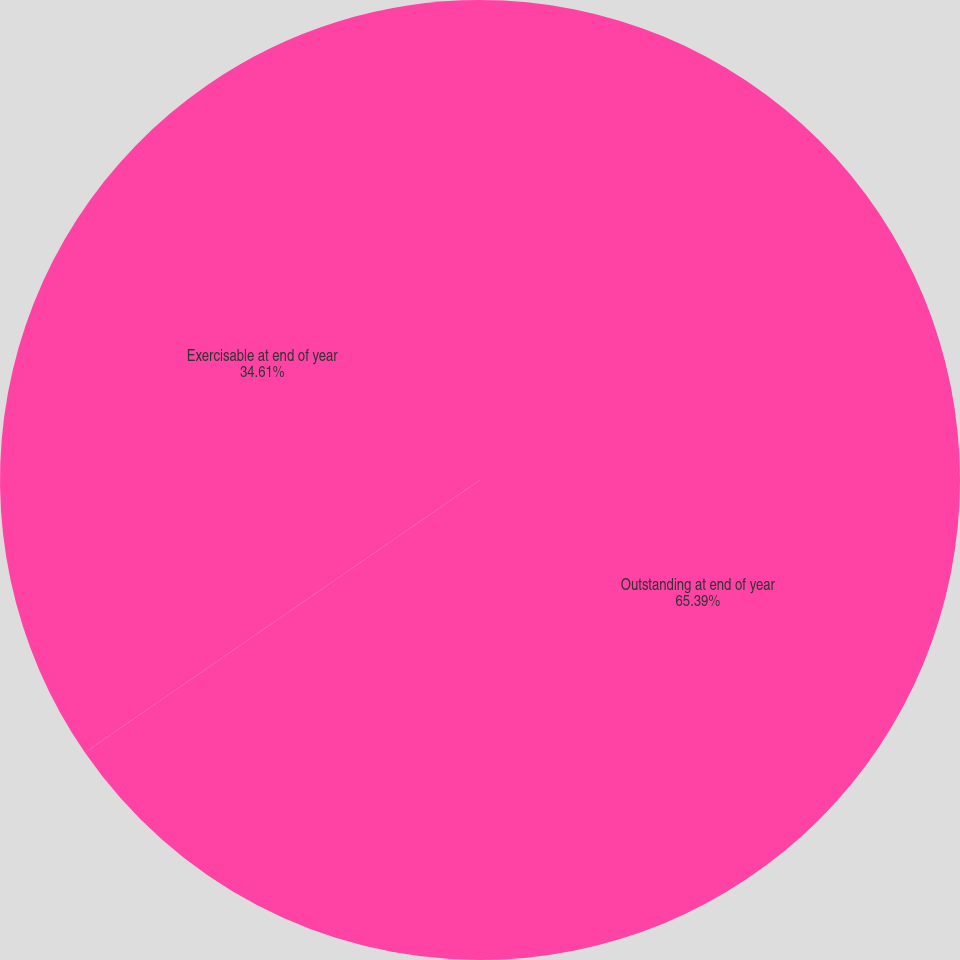<chart> <loc_0><loc_0><loc_500><loc_500><pie_chart><fcel>Outstanding at end of year<fcel>Exercisable at end of year<nl><fcel>65.39%<fcel>34.61%<nl></chart> 